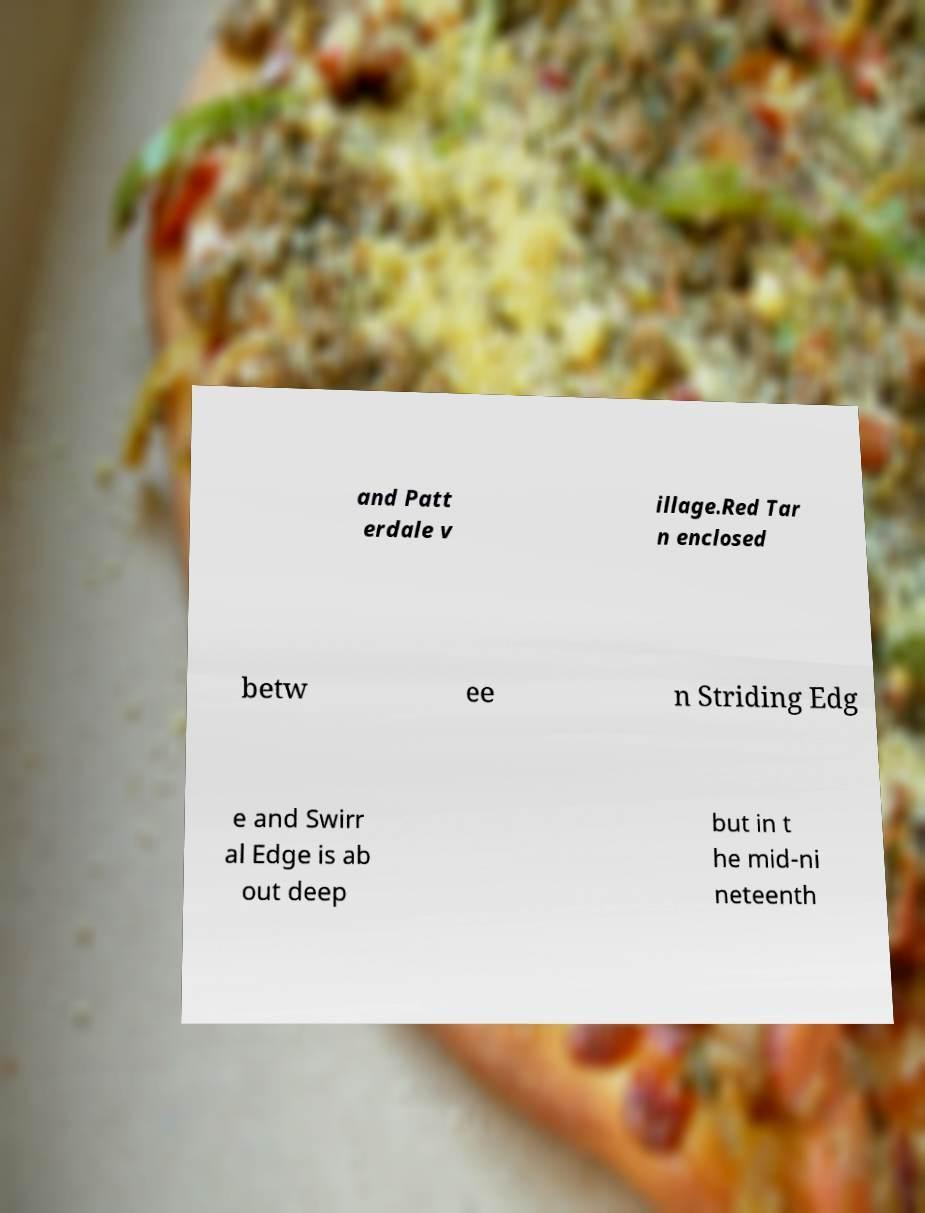Can you read and provide the text displayed in the image?This photo seems to have some interesting text. Can you extract and type it out for me? and Patt erdale v illage.Red Tar n enclosed betw ee n Striding Edg e and Swirr al Edge is ab out deep but in t he mid-ni neteenth 